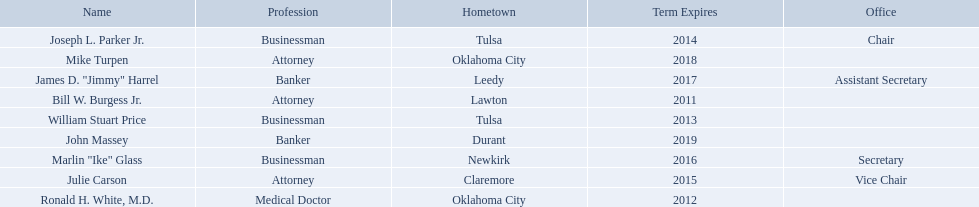Who are the businessmen? Bill W. Burgess Jr., Ronald H. White, M.D., William Stuart Price, Joseph L. Parker Jr., Julie Carson, Marlin "Ike" Glass, James D. "Jimmy" Harrel, Mike Turpen, John Massey. Which were born in tulsa? William Stuart Price, Joseph L. Parker Jr. Of these, which one was other than william stuart price? Joseph L. Parker Jr. What are all of the names? Bill W. Burgess Jr., Ronald H. White, M.D., William Stuart Price, Joseph L. Parker Jr., Julie Carson, Marlin "Ike" Glass, James D. "Jimmy" Harrel, Mike Turpen, John Massey. Where is each member from? Lawton, Oklahoma City, Tulsa, Tulsa, Claremore, Newkirk, Leedy, Oklahoma City, Durant. Along with joseph l. parker jr., which other member is from tulsa? William Stuart Price. Who are the state regents? Bill W. Burgess Jr., Ronald H. White, M.D., William Stuart Price, Joseph L. Parker Jr., Julie Carson, Marlin "Ike" Glass, James D. "Jimmy" Harrel, Mike Turpen, John Massey. Of those state regents, who is from the same hometown as ronald h. white, m.d.? Mike Turpen. 